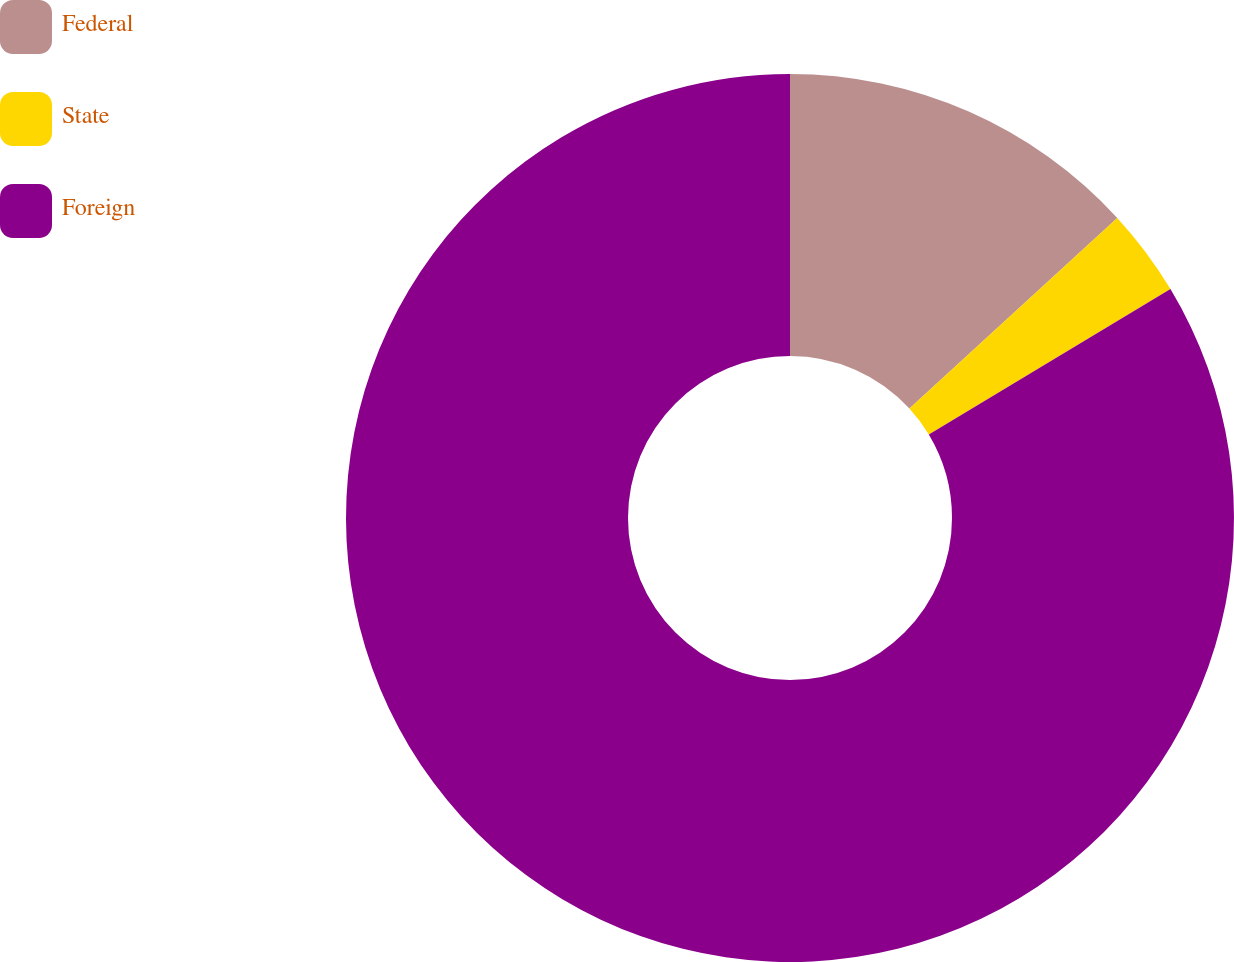<chart> <loc_0><loc_0><loc_500><loc_500><pie_chart><fcel>Federal<fcel>State<fcel>Foreign<nl><fcel>13.19%<fcel>3.19%<fcel>83.62%<nl></chart> 